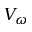<formula> <loc_0><loc_0><loc_500><loc_500>V _ { \omega }</formula> 